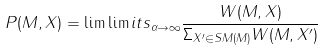<formula> <loc_0><loc_0><loc_500><loc_500>P ( M , X ) = \lim \lim i t s _ { \alpha \rightarrow \infty } \frac { W ( M , X ) } { \Sigma _ { X ^ { \prime } \in S M ( M ) } W ( M , X ^ { \prime } ) }</formula> 